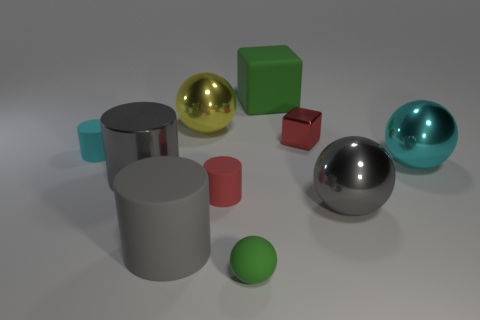Subtract 1 cylinders. How many cylinders are left? 3 Subtract all spheres. How many objects are left? 6 Subtract 0 cyan blocks. How many objects are left? 10 Subtract all large gray cylinders. Subtract all big gray cylinders. How many objects are left? 6 Add 6 tiny green spheres. How many tiny green spheres are left? 7 Add 9 rubber balls. How many rubber balls exist? 10 